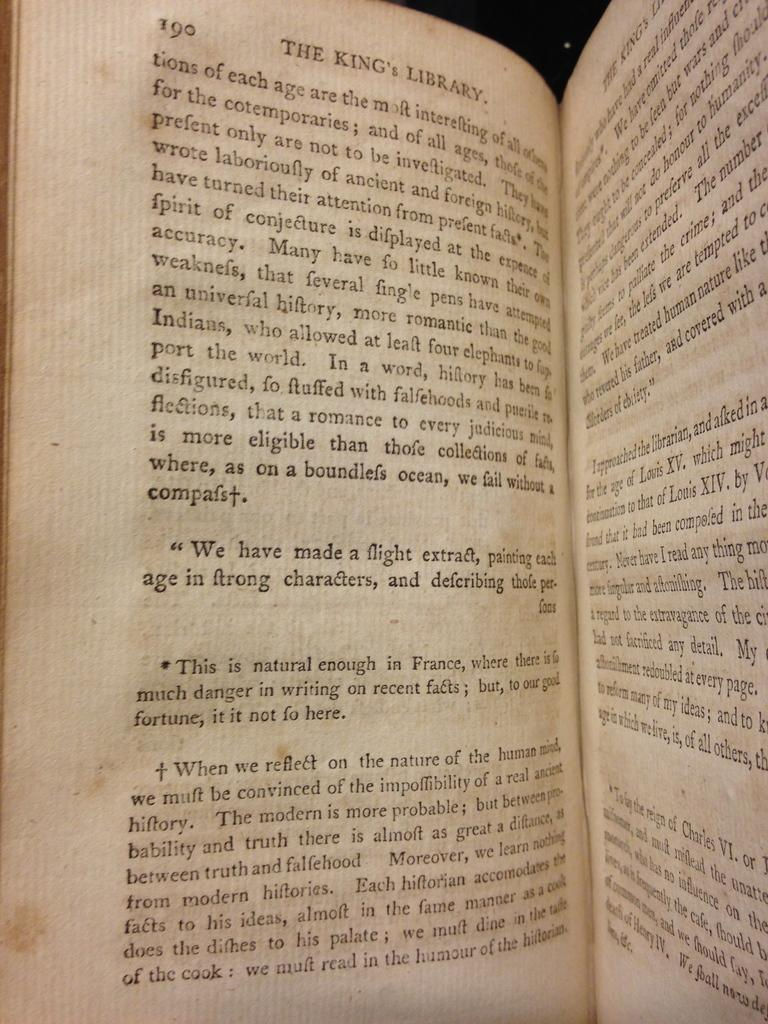<image>
Relay a brief, clear account of the picture shown. A hardback book of The King's Library open to page 190. 